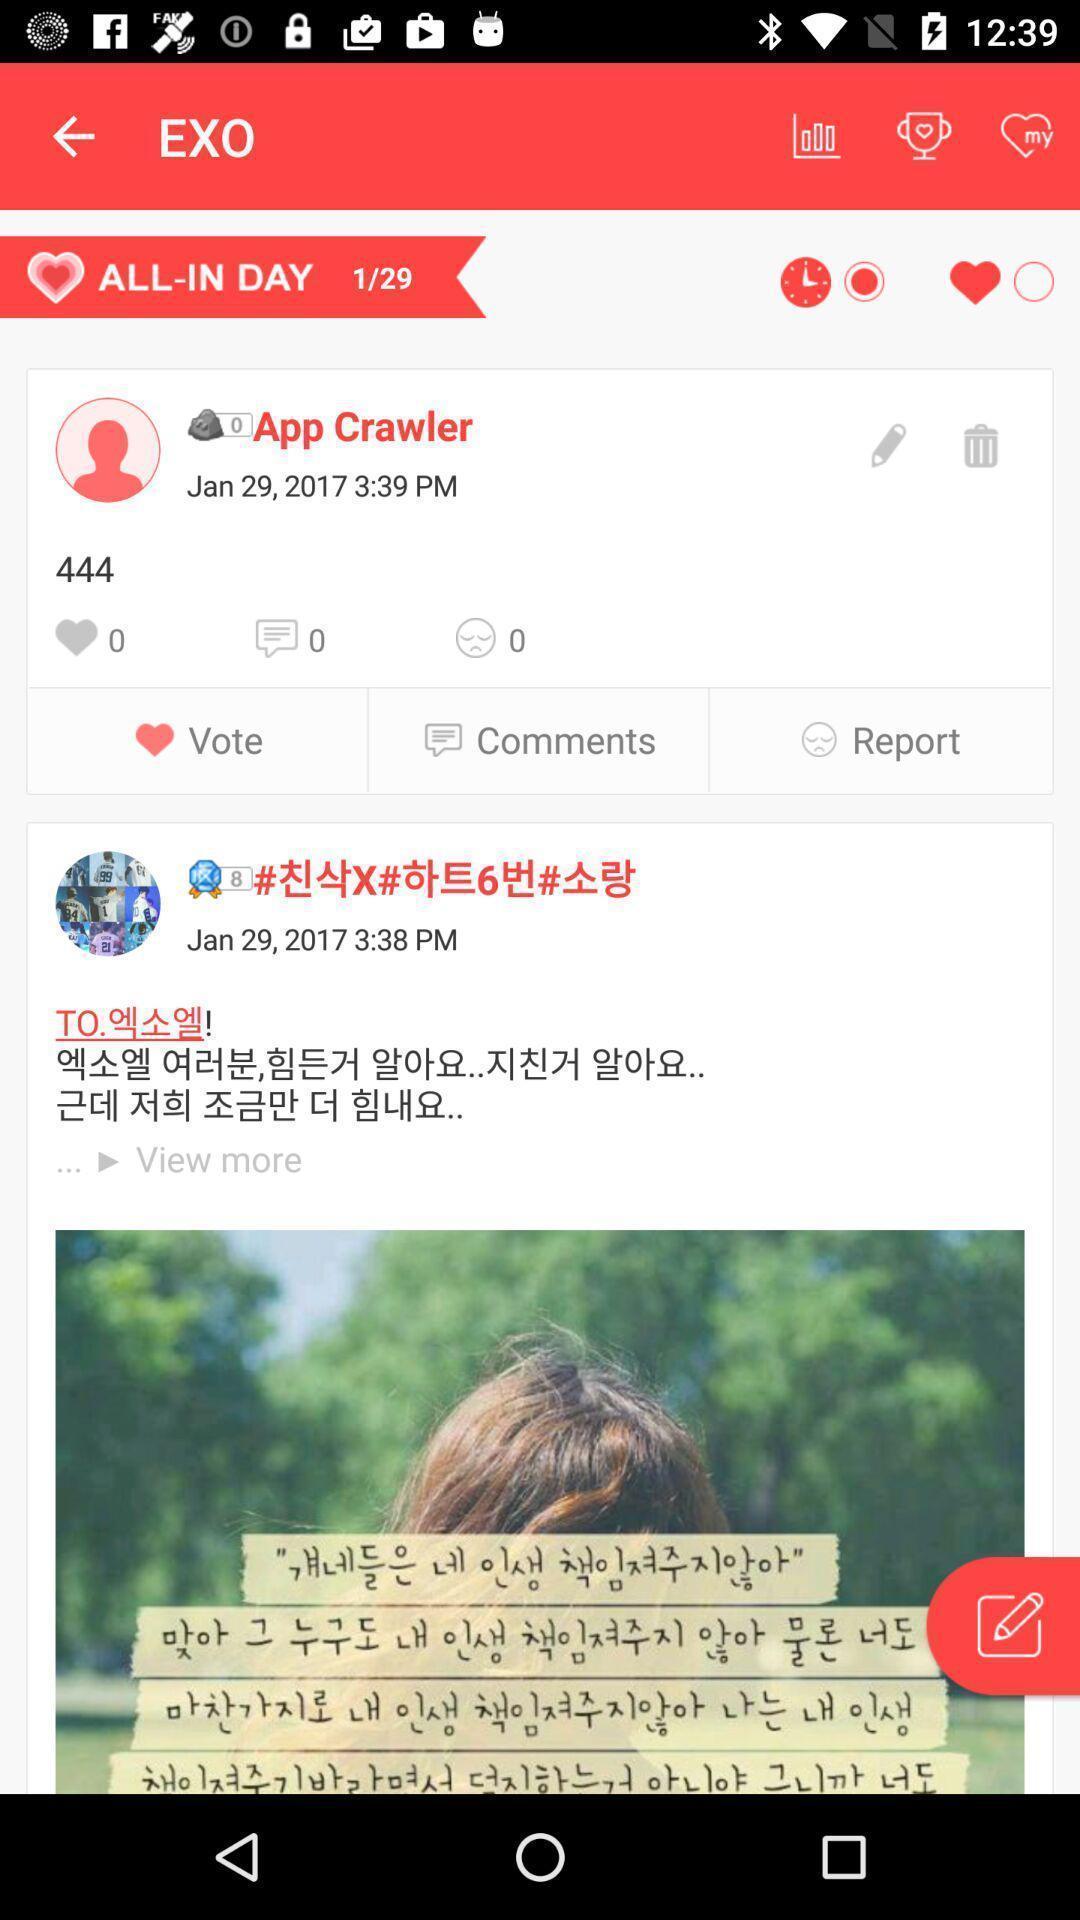What is the overall content of this screenshot? Screen displaying posts of different app users. 